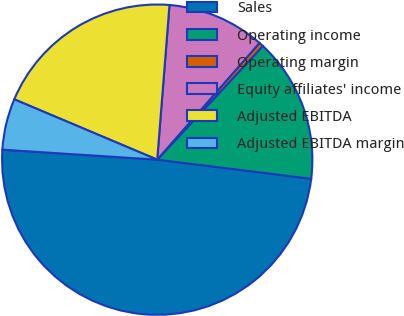Convert chart. <chart><loc_0><loc_0><loc_500><loc_500><pie_chart><fcel>Sales<fcel>Operating income<fcel>Operating margin<fcel>Equity affiliates' income<fcel>Adjusted EBITDA<fcel>Adjusted EBITDA margin<nl><fcel>49.07%<fcel>15.05%<fcel>0.47%<fcel>10.19%<fcel>19.91%<fcel>5.33%<nl></chart> 